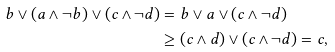Convert formula to latex. <formula><loc_0><loc_0><loc_500><loc_500>b \vee ( a \wedge \neg b ) \vee ( c \wedge \neg d ) & = b \vee a \vee ( c \wedge \neg d ) \\ & \geq ( c \wedge d ) \vee ( c \wedge \neg d ) = c ,</formula> 